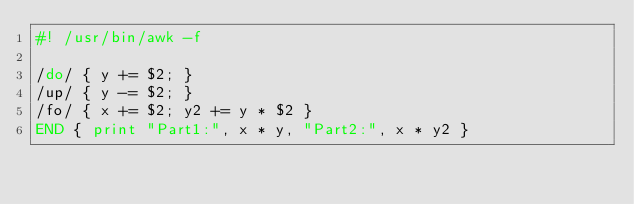<code> <loc_0><loc_0><loc_500><loc_500><_Awk_>#! /usr/bin/awk -f

/do/ { y += $2; }
/up/ { y -= $2; }
/fo/ { x += $2; y2 += y * $2 }
END { print "Part1:", x * y, "Part2:", x * y2 }</code> 